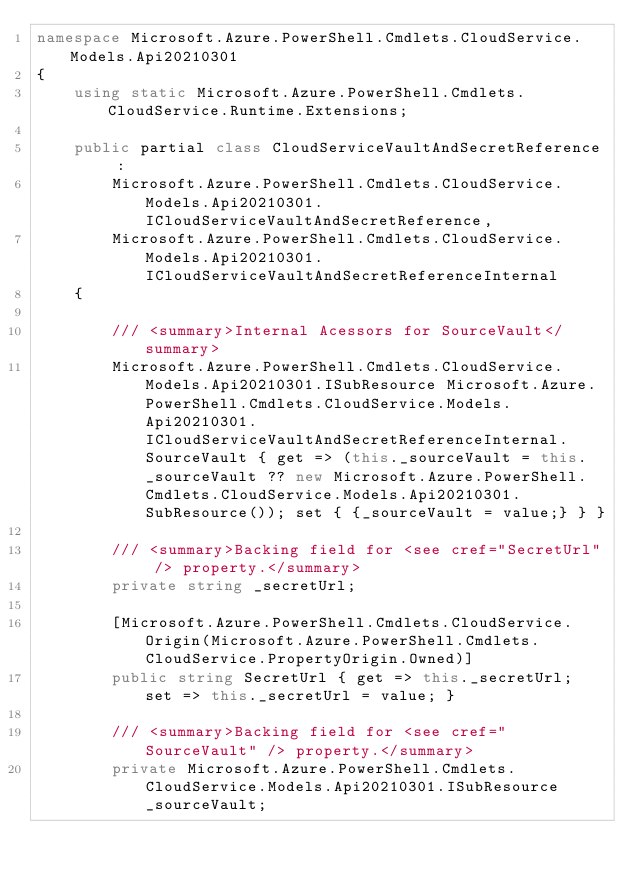Convert code to text. <code><loc_0><loc_0><loc_500><loc_500><_C#_>namespace Microsoft.Azure.PowerShell.Cmdlets.CloudService.Models.Api20210301
{
    using static Microsoft.Azure.PowerShell.Cmdlets.CloudService.Runtime.Extensions;

    public partial class CloudServiceVaultAndSecretReference :
        Microsoft.Azure.PowerShell.Cmdlets.CloudService.Models.Api20210301.ICloudServiceVaultAndSecretReference,
        Microsoft.Azure.PowerShell.Cmdlets.CloudService.Models.Api20210301.ICloudServiceVaultAndSecretReferenceInternal
    {

        /// <summary>Internal Acessors for SourceVault</summary>
        Microsoft.Azure.PowerShell.Cmdlets.CloudService.Models.Api20210301.ISubResource Microsoft.Azure.PowerShell.Cmdlets.CloudService.Models.Api20210301.ICloudServiceVaultAndSecretReferenceInternal.SourceVault { get => (this._sourceVault = this._sourceVault ?? new Microsoft.Azure.PowerShell.Cmdlets.CloudService.Models.Api20210301.SubResource()); set { {_sourceVault = value;} } }

        /// <summary>Backing field for <see cref="SecretUrl" /> property.</summary>
        private string _secretUrl;

        [Microsoft.Azure.PowerShell.Cmdlets.CloudService.Origin(Microsoft.Azure.PowerShell.Cmdlets.CloudService.PropertyOrigin.Owned)]
        public string SecretUrl { get => this._secretUrl; set => this._secretUrl = value; }

        /// <summary>Backing field for <see cref="SourceVault" /> property.</summary>
        private Microsoft.Azure.PowerShell.Cmdlets.CloudService.Models.Api20210301.ISubResource _sourceVault;
</code> 